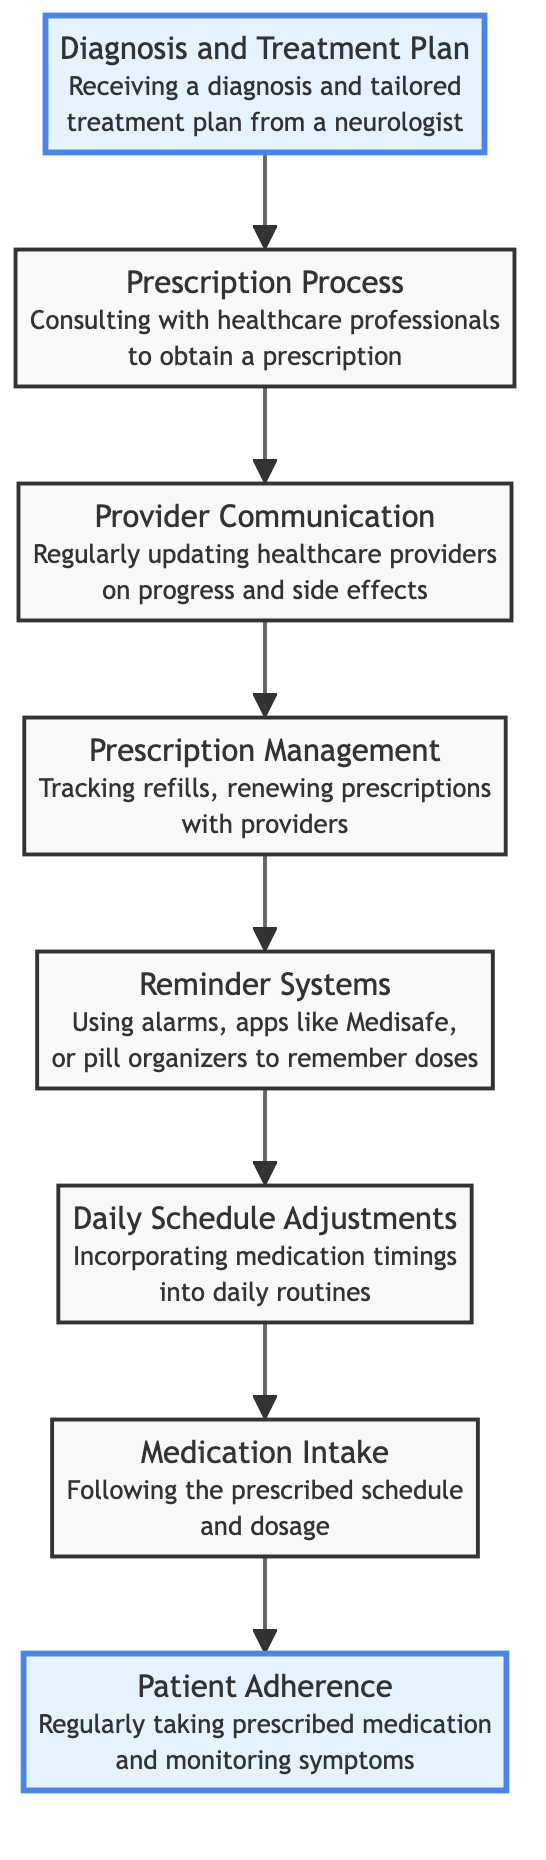What is the top node in the diagram? The top node in the diagram represents the final outcome of the process, which is "Patient Adherence."
Answer: Patient Adherence How many levels are present in this flowchart? The flowchart consists of 8 distinct levels that represent different stages in the medication management process.
Answer: 8 What comes immediately after "Provider Communication"? The node that follows "Provider Communication" is "Prescription Management," indicating the next step in the flow after updating healthcare providers.
Answer: Prescription Management Which node describes the use of reminders? The node that discusses the use of reminders, such as alarms and apps, is "Reminder Systems." This node specifically addresses tools that help in remembering doses.
Answer: Reminder Systems What is the relationship between "Diagnosis and Treatment Plan" and "Patient Adherence"? "Diagnosis and Treatment Plan" is the starting point of the diagram and is necessary for achieving "Patient Adherence" as it leads through the entire process of medication management to adherence.
Answer: Leads to What does "Daily Schedule Adjustments" relate to directly? "Daily Schedule Adjustments" directly relates to "Medication Intake," as this node explains how adjustments to the schedule assist in following the prescribed intake of medication.
Answer: Medication Intake What is the final step before achieving patient adherence? The final step before achieving patient adherence is "Medication Intake," which involves following the prescribed schedule and dosage.
Answer: Medication Intake How many nodes detail the prescription process? There are three nodes that detail the prescription process: "Diagnosis and Treatment Plan," "Prescription Process," and "Provider Communication," indicating the steps involved from diagnosis to communicating with providers.
Answer: 3 